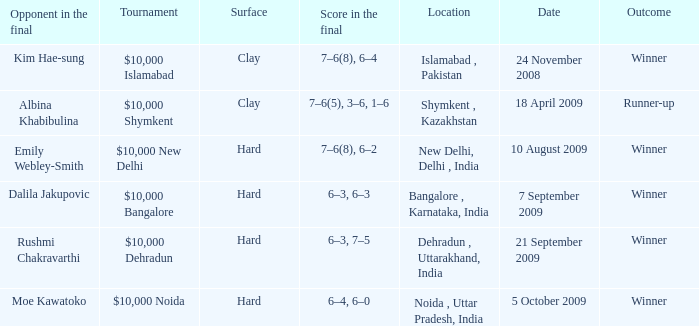What is the material of the surface in the dehradun , uttarakhand, india location Hard. 